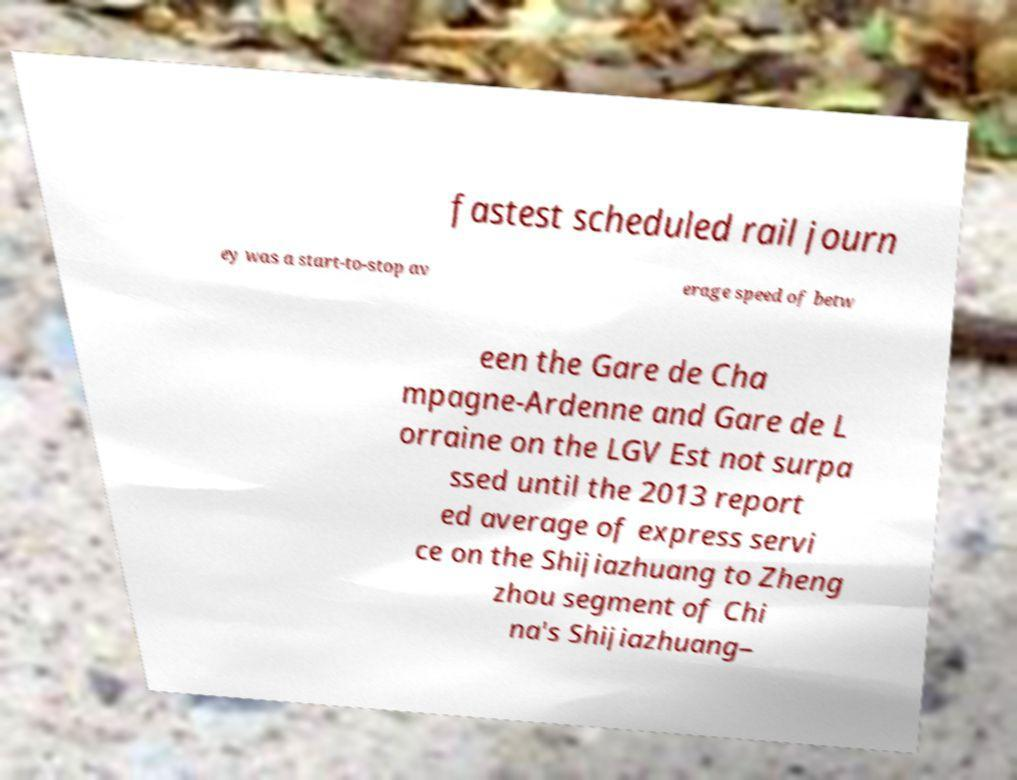Please identify and transcribe the text found in this image. fastest scheduled rail journ ey was a start-to-stop av erage speed of betw een the Gare de Cha mpagne-Ardenne and Gare de L orraine on the LGV Est not surpa ssed until the 2013 report ed average of express servi ce on the Shijiazhuang to Zheng zhou segment of Chi na's Shijiazhuang– 